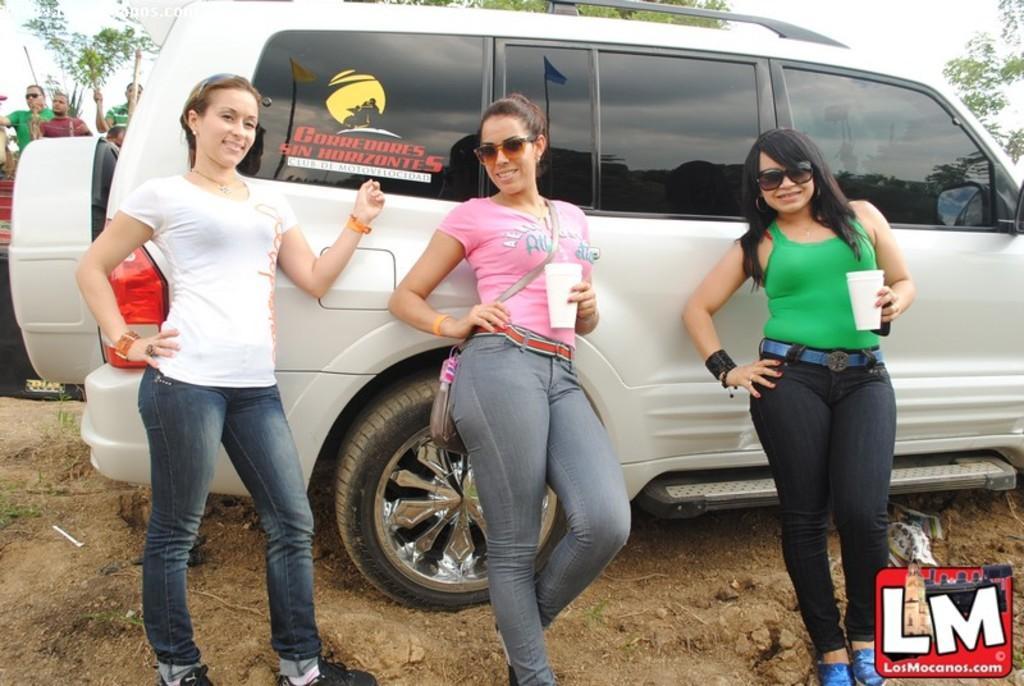Please provide a concise description of this image. In this image I can see three women are standing and I can see two of them are wearing goggles and holding white colored cups in their hands. I can see a white colored car behind them and in the background I can see few persons, few trees and the sky. 